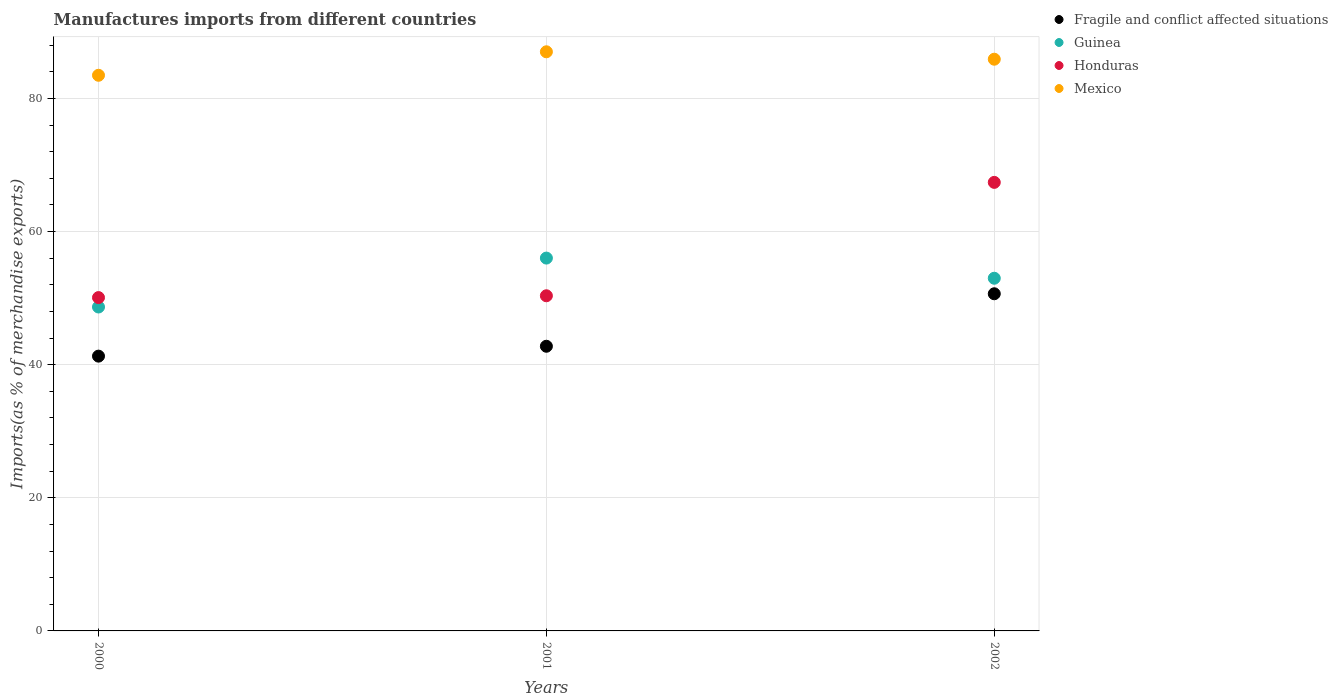What is the percentage of imports to different countries in Mexico in 2001?
Make the answer very short. 87. Across all years, what is the maximum percentage of imports to different countries in Mexico?
Your answer should be compact. 87. Across all years, what is the minimum percentage of imports to different countries in Mexico?
Provide a short and direct response. 83.48. In which year was the percentage of imports to different countries in Honduras minimum?
Your answer should be compact. 2000. What is the total percentage of imports to different countries in Honduras in the graph?
Your answer should be compact. 167.82. What is the difference between the percentage of imports to different countries in Fragile and conflict affected situations in 2001 and that in 2002?
Give a very brief answer. -7.89. What is the difference between the percentage of imports to different countries in Guinea in 2002 and the percentage of imports to different countries in Honduras in 2001?
Your answer should be compact. 2.63. What is the average percentage of imports to different countries in Honduras per year?
Your answer should be compact. 55.94. In the year 2000, what is the difference between the percentage of imports to different countries in Mexico and percentage of imports to different countries in Honduras?
Your answer should be compact. 33.4. What is the ratio of the percentage of imports to different countries in Mexico in 2000 to that in 2001?
Your response must be concise. 0.96. What is the difference between the highest and the second highest percentage of imports to different countries in Honduras?
Provide a short and direct response. 17.04. What is the difference between the highest and the lowest percentage of imports to different countries in Guinea?
Provide a short and direct response. 7.35. In how many years, is the percentage of imports to different countries in Mexico greater than the average percentage of imports to different countries in Mexico taken over all years?
Your answer should be compact. 2. Is it the case that in every year, the sum of the percentage of imports to different countries in Mexico and percentage of imports to different countries in Guinea  is greater than the percentage of imports to different countries in Fragile and conflict affected situations?
Your response must be concise. Yes. Does the percentage of imports to different countries in Fragile and conflict affected situations monotonically increase over the years?
Your answer should be very brief. Yes. Is the percentage of imports to different countries in Mexico strictly greater than the percentage of imports to different countries in Honduras over the years?
Your response must be concise. Yes. Is the percentage of imports to different countries in Guinea strictly less than the percentage of imports to different countries in Honduras over the years?
Offer a terse response. No. How many dotlines are there?
Ensure brevity in your answer.  4. How many years are there in the graph?
Give a very brief answer. 3. Are the values on the major ticks of Y-axis written in scientific E-notation?
Provide a succinct answer. No. Where does the legend appear in the graph?
Your answer should be compact. Top right. How are the legend labels stacked?
Provide a short and direct response. Vertical. What is the title of the graph?
Provide a short and direct response. Manufactures imports from different countries. What is the label or title of the X-axis?
Make the answer very short. Years. What is the label or title of the Y-axis?
Provide a short and direct response. Imports(as % of merchandise exports). What is the Imports(as % of merchandise exports) of Fragile and conflict affected situations in 2000?
Your response must be concise. 41.28. What is the Imports(as % of merchandise exports) of Guinea in 2000?
Provide a short and direct response. 48.66. What is the Imports(as % of merchandise exports) in Honduras in 2000?
Provide a succinct answer. 50.08. What is the Imports(as % of merchandise exports) in Mexico in 2000?
Provide a succinct answer. 83.48. What is the Imports(as % of merchandise exports) of Fragile and conflict affected situations in 2001?
Your answer should be compact. 42.77. What is the Imports(as % of merchandise exports) of Guinea in 2001?
Your answer should be compact. 56.01. What is the Imports(as % of merchandise exports) in Honduras in 2001?
Provide a short and direct response. 50.35. What is the Imports(as % of merchandise exports) of Mexico in 2001?
Provide a succinct answer. 87. What is the Imports(as % of merchandise exports) of Fragile and conflict affected situations in 2002?
Provide a short and direct response. 50.65. What is the Imports(as % of merchandise exports) in Guinea in 2002?
Offer a terse response. 52.98. What is the Imports(as % of merchandise exports) of Honduras in 2002?
Provide a short and direct response. 67.39. What is the Imports(as % of merchandise exports) of Mexico in 2002?
Offer a terse response. 85.89. Across all years, what is the maximum Imports(as % of merchandise exports) of Fragile and conflict affected situations?
Your response must be concise. 50.65. Across all years, what is the maximum Imports(as % of merchandise exports) of Guinea?
Ensure brevity in your answer.  56.01. Across all years, what is the maximum Imports(as % of merchandise exports) in Honduras?
Offer a terse response. 67.39. Across all years, what is the maximum Imports(as % of merchandise exports) in Mexico?
Your answer should be very brief. 87. Across all years, what is the minimum Imports(as % of merchandise exports) in Fragile and conflict affected situations?
Offer a very short reply. 41.28. Across all years, what is the minimum Imports(as % of merchandise exports) in Guinea?
Offer a terse response. 48.66. Across all years, what is the minimum Imports(as % of merchandise exports) of Honduras?
Keep it short and to the point. 50.08. Across all years, what is the minimum Imports(as % of merchandise exports) of Mexico?
Give a very brief answer. 83.48. What is the total Imports(as % of merchandise exports) in Fragile and conflict affected situations in the graph?
Your answer should be very brief. 134.7. What is the total Imports(as % of merchandise exports) in Guinea in the graph?
Offer a terse response. 157.66. What is the total Imports(as % of merchandise exports) in Honduras in the graph?
Make the answer very short. 167.82. What is the total Imports(as % of merchandise exports) of Mexico in the graph?
Your answer should be compact. 256.37. What is the difference between the Imports(as % of merchandise exports) in Fragile and conflict affected situations in 2000 and that in 2001?
Offer a very short reply. -1.48. What is the difference between the Imports(as % of merchandise exports) in Guinea in 2000 and that in 2001?
Ensure brevity in your answer.  -7.35. What is the difference between the Imports(as % of merchandise exports) in Honduras in 2000 and that in 2001?
Keep it short and to the point. -0.27. What is the difference between the Imports(as % of merchandise exports) in Mexico in 2000 and that in 2001?
Offer a very short reply. -3.53. What is the difference between the Imports(as % of merchandise exports) of Fragile and conflict affected situations in 2000 and that in 2002?
Offer a very short reply. -9.37. What is the difference between the Imports(as % of merchandise exports) of Guinea in 2000 and that in 2002?
Your answer should be very brief. -4.32. What is the difference between the Imports(as % of merchandise exports) in Honduras in 2000 and that in 2002?
Provide a succinct answer. -17.31. What is the difference between the Imports(as % of merchandise exports) of Mexico in 2000 and that in 2002?
Ensure brevity in your answer.  -2.41. What is the difference between the Imports(as % of merchandise exports) in Fragile and conflict affected situations in 2001 and that in 2002?
Offer a terse response. -7.89. What is the difference between the Imports(as % of merchandise exports) of Guinea in 2001 and that in 2002?
Provide a succinct answer. 3.03. What is the difference between the Imports(as % of merchandise exports) in Honduras in 2001 and that in 2002?
Ensure brevity in your answer.  -17.04. What is the difference between the Imports(as % of merchandise exports) in Mexico in 2001 and that in 2002?
Offer a terse response. 1.11. What is the difference between the Imports(as % of merchandise exports) of Fragile and conflict affected situations in 2000 and the Imports(as % of merchandise exports) of Guinea in 2001?
Provide a short and direct response. -14.73. What is the difference between the Imports(as % of merchandise exports) in Fragile and conflict affected situations in 2000 and the Imports(as % of merchandise exports) in Honduras in 2001?
Offer a terse response. -9.07. What is the difference between the Imports(as % of merchandise exports) in Fragile and conflict affected situations in 2000 and the Imports(as % of merchandise exports) in Mexico in 2001?
Give a very brief answer. -45.72. What is the difference between the Imports(as % of merchandise exports) in Guinea in 2000 and the Imports(as % of merchandise exports) in Honduras in 2001?
Ensure brevity in your answer.  -1.69. What is the difference between the Imports(as % of merchandise exports) of Guinea in 2000 and the Imports(as % of merchandise exports) of Mexico in 2001?
Ensure brevity in your answer.  -38.34. What is the difference between the Imports(as % of merchandise exports) in Honduras in 2000 and the Imports(as % of merchandise exports) in Mexico in 2001?
Provide a succinct answer. -36.93. What is the difference between the Imports(as % of merchandise exports) in Fragile and conflict affected situations in 2000 and the Imports(as % of merchandise exports) in Guinea in 2002?
Provide a short and direct response. -11.7. What is the difference between the Imports(as % of merchandise exports) of Fragile and conflict affected situations in 2000 and the Imports(as % of merchandise exports) of Honduras in 2002?
Your answer should be compact. -26.1. What is the difference between the Imports(as % of merchandise exports) in Fragile and conflict affected situations in 2000 and the Imports(as % of merchandise exports) in Mexico in 2002?
Give a very brief answer. -44.61. What is the difference between the Imports(as % of merchandise exports) of Guinea in 2000 and the Imports(as % of merchandise exports) of Honduras in 2002?
Your response must be concise. -18.72. What is the difference between the Imports(as % of merchandise exports) in Guinea in 2000 and the Imports(as % of merchandise exports) in Mexico in 2002?
Offer a terse response. -37.23. What is the difference between the Imports(as % of merchandise exports) of Honduras in 2000 and the Imports(as % of merchandise exports) of Mexico in 2002?
Keep it short and to the point. -35.81. What is the difference between the Imports(as % of merchandise exports) of Fragile and conflict affected situations in 2001 and the Imports(as % of merchandise exports) of Guinea in 2002?
Offer a terse response. -10.22. What is the difference between the Imports(as % of merchandise exports) in Fragile and conflict affected situations in 2001 and the Imports(as % of merchandise exports) in Honduras in 2002?
Make the answer very short. -24.62. What is the difference between the Imports(as % of merchandise exports) in Fragile and conflict affected situations in 2001 and the Imports(as % of merchandise exports) in Mexico in 2002?
Keep it short and to the point. -43.12. What is the difference between the Imports(as % of merchandise exports) in Guinea in 2001 and the Imports(as % of merchandise exports) in Honduras in 2002?
Provide a succinct answer. -11.37. What is the difference between the Imports(as % of merchandise exports) of Guinea in 2001 and the Imports(as % of merchandise exports) of Mexico in 2002?
Provide a succinct answer. -29.88. What is the difference between the Imports(as % of merchandise exports) of Honduras in 2001 and the Imports(as % of merchandise exports) of Mexico in 2002?
Your answer should be very brief. -35.54. What is the average Imports(as % of merchandise exports) of Fragile and conflict affected situations per year?
Provide a short and direct response. 44.9. What is the average Imports(as % of merchandise exports) in Guinea per year?
Your answer should be very brief. 52.55. What is the average Imports(as % of merchandise exports) in Honduras per year?
Keep it short and to the point. 55.94. What is the average Imports(as % of merchandise exports) in Mexico per year?
Provide a succinct answer. 85.46. In the year 2000, what is the difference between the Imports(as % of merchandise exports) of Fragile and conflict affected situations and Imports(as % of merchandise exports) of Guinea?
Keep it short and to the point. -7.38. In the year 2000, what is the difference between the Imports(as % of merchandise exports) of Fragile and conflict affected situations and Imports(as % of merchandise exports) of Honduras?
Your answer should be compact. -8.8. In the year 2000, what is the difference between the Imports(as % of merchandise exports) of Fragile and conflict affected situations and Imports(as % of merchandise exports) of Mexico?
Make the answer very short. -42.19. In the year 2000, what is the difference between the Imports(as % of merchandise exports) in Guinea and Imports(as % of merchandise exports) in Honduras?
Provide a short and direct response. -1.41. In the year 2000, what is the difference between the Imports(as % of merchandise exports) of Guinea and Imports(as % of merchandise exports) of Mexico?
Keep it short and to the point. -34.81. In the year 2000, what is the difference between the Imports(as % of merchandise exports) in Honduras and Imports(as % of merchandise exports) in Mexico?
Your answer should be very brief. -33.4. In the year 2001, what is the difference between the Imports(as % of merchandise exports) of Fragile and conflict affected situations and Imports(as % of merchandise exports) of Guinea?
Make the answer very short. -13.25. In the year 2001, what is the difference between the Imports(as % of merchandise exports) of Fragile and conflict affected situations and Imports(as % of merchandise exports) of Honduras?
Provide a succinct answer. -7.58. In the year 2001, what is the difference between the Imports(as % of merchandise exports) in Fragile and conflict affected situations and Imports(as % of merchandise exports) in Mexico?
Ensure brevity in your answer.  -44.24. In the year 2001, what is the difference between the Imports(as % of merchandise exports) of Guinea and Imports(as % of merchandise exports) of Honduras?
Your answer should be very brief. 5.66. In the year 2001, what is the difference between the Imports(as % of merchandise exports) in Guinea and Imports(as % of merchandise exports) in Mexico?
Give a very brief answer. -30.99. In the year 2001, what is the difference between the Imports(as % of merchandise exports) in Honduras and Imports(as % of merchandise exports) in Mexico?
Keep it short and to the point. -36.65. In the year 2002, what is the difference between the Imports(as % of merchandise exports) of Fragile and conflict affected situations and Imports(as % of merchandise exports) of Guinea?
Make the answer very short. -2.33. In the year 2002, what is the difference between the Imports(as % of merchandise exports) of Fragile and conflict affected situations and Imports(as % of merchandise exports) of Honduras?
Provide a succinct answer. -16.73. In the year 2002, what is the difference between the Imports(as % of merchandise exports) in Fragile and conflict affected situations and Imports(as % of merchandise exports) in Mexico?
Your answer should be very brief. -35.24. In the year 2002, what is the difference between the Imports(as % of merchandise exports) of Guinea and Imports(as % of merchandise exports) of Honduras?
Ensure brevity in your answer.  -14.4. In the year 2002, what is the difference between the Imports(as % of merchandise exports) of Guinea and Imports(as % of merchandise exports) of Mexico?
Your answer should be compact. -32.91. In the year 2002, what is the difference between the Imports(as % of merchandise exports) in Honduras and Imports(as % of merchandise exports) in Mexico?
Offer a very short reply. -18.5. What is the ratio of the Imports(as % of merchandise exports) of Fragile and conflict affected situations in 2000 to that in 2001?
Offer a very short reply. 0.97. What is the ratio of the Imports(as % of merchandise exports) in Guinea in 2000 to that in 2001?
Your response must be concise. 0.87. What is the ratio of the Imports(as % of merchandise exports) of Honduras in 2000 to that in 2001?
Offer a very short reply. 0.99. What is the ratio of the Imports(as % of merchandise exports) in Mexico in 2000 to that in 2001?
Offer a terse response. 0.96. What is the ratio of the Imports(as % of merchandise exports) in Fragile and conflict affected situations in 2000 to that in 2002?
Your answer should be compact. 0.81. What is the ratio of the Imports(as % of merchandise exports) of Guinea in 2000 to that in 2002?
Your answer should be very brief. 0.92. What is the ratio of the Imports(as % of merchandise exports) in Honduras in 2000 to that in 2002?
Make the answer very short. 0.74. What is the ratio of the Imports(as % of merchandise exports) in Mexico in 2000 to that in 2002?
Offer a terse response. 0.97. What is the ratio of the Imports(as % of merchandise exports) in Fragile and conflict affected situations in 2001 to that in 2002?
Provide a succinct answer. 0.84. What is the ratio of the Imports(as % of merchandise exports) of Guinea in 2001 to that in 2002?
Keep it short and to the point. 1.06. What is the ratio of the Imports(as % of merchandise exports) in Honduras in 2001 to that in 2002?
Your answer should be very brief. 0.75. What is the ratio of the Imports(as % of merchandise exports) of Mexico in 2001 to that in 2002?
Your answer should be very brief. 1.01. What is the difference between the highest and the second highest Imports(as % of merchandise exports) of Fragile and conflict affected situations?
Offer a very short reply. 7.89. What is the difference between the highest and the second highest Imports(as % of merchandise exports) of Guinea?
Offer a very short reply. 3.03. What is the difference between the highest and the second highest Imports(as % of merchandise exports) in Honduras?
Offer a very short reply. 17.04. What is the difference between the highest and the second highest Imports(as % of merchandise exports) of Mexico?
Give a very brief answer. 1.11. What is the difference between the highest and the lowest Imports(as % of merchandise exports) of Fragile and conflict affected situations?
Ensure brevity in your answer.  9.37. What is the difference between the highest and the lowest Imports(as % of merchandise exports) of Guinea?
Make the answer very short. 7.35. What is the difference between the highest and the lowest Imports(as % of merchandise exports) in Honduras?
Ensure brevity in your answer.  17.31. What is the difference between the highest and the lowest Imports(as % of merchandise exports) in Mexico?
Offer a terse response. 3.53. 